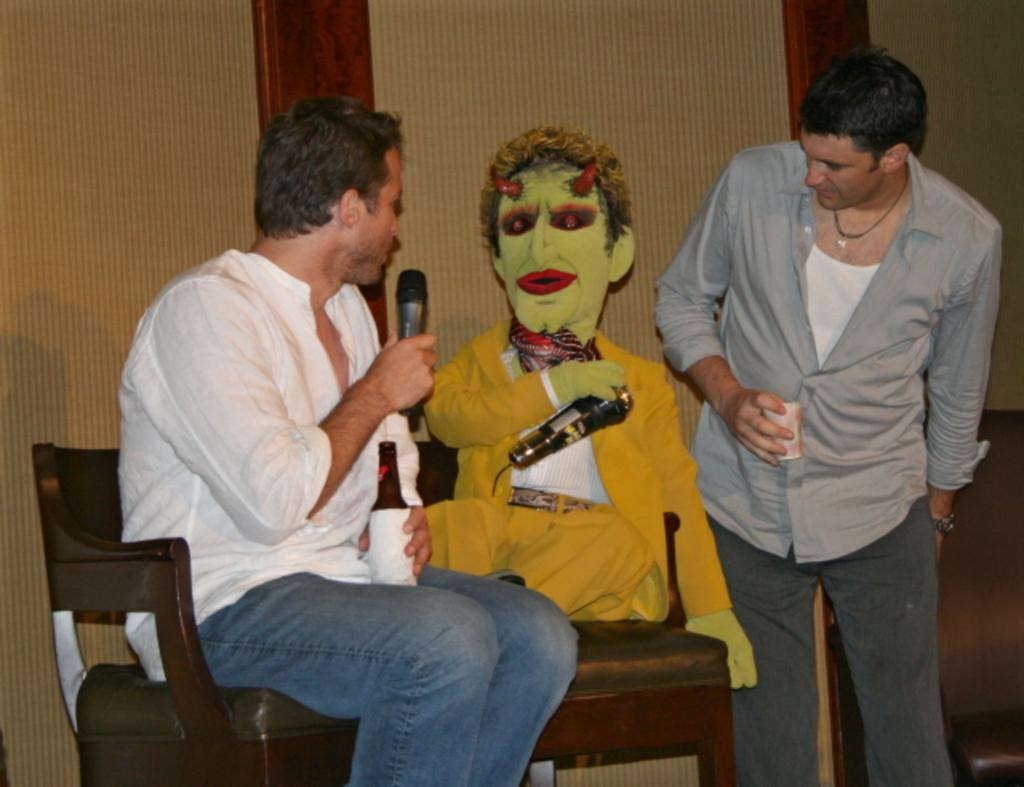What is the man in the image doing? The man is sitting on a chair and holding a microphone in the image. Can you describe the other person in the image? There is another man standing in the image, and he is looking at a doll. What can be seen in the background of the image? There is a wall visible in the background of the image. What type of flowers can be seen in the image? There are no flowers present in the image. How many servants are visible in the image? There is no mention of servants in the image; it features two men, one sitting and holding a microphone, and the other standing and looking at a doll. 